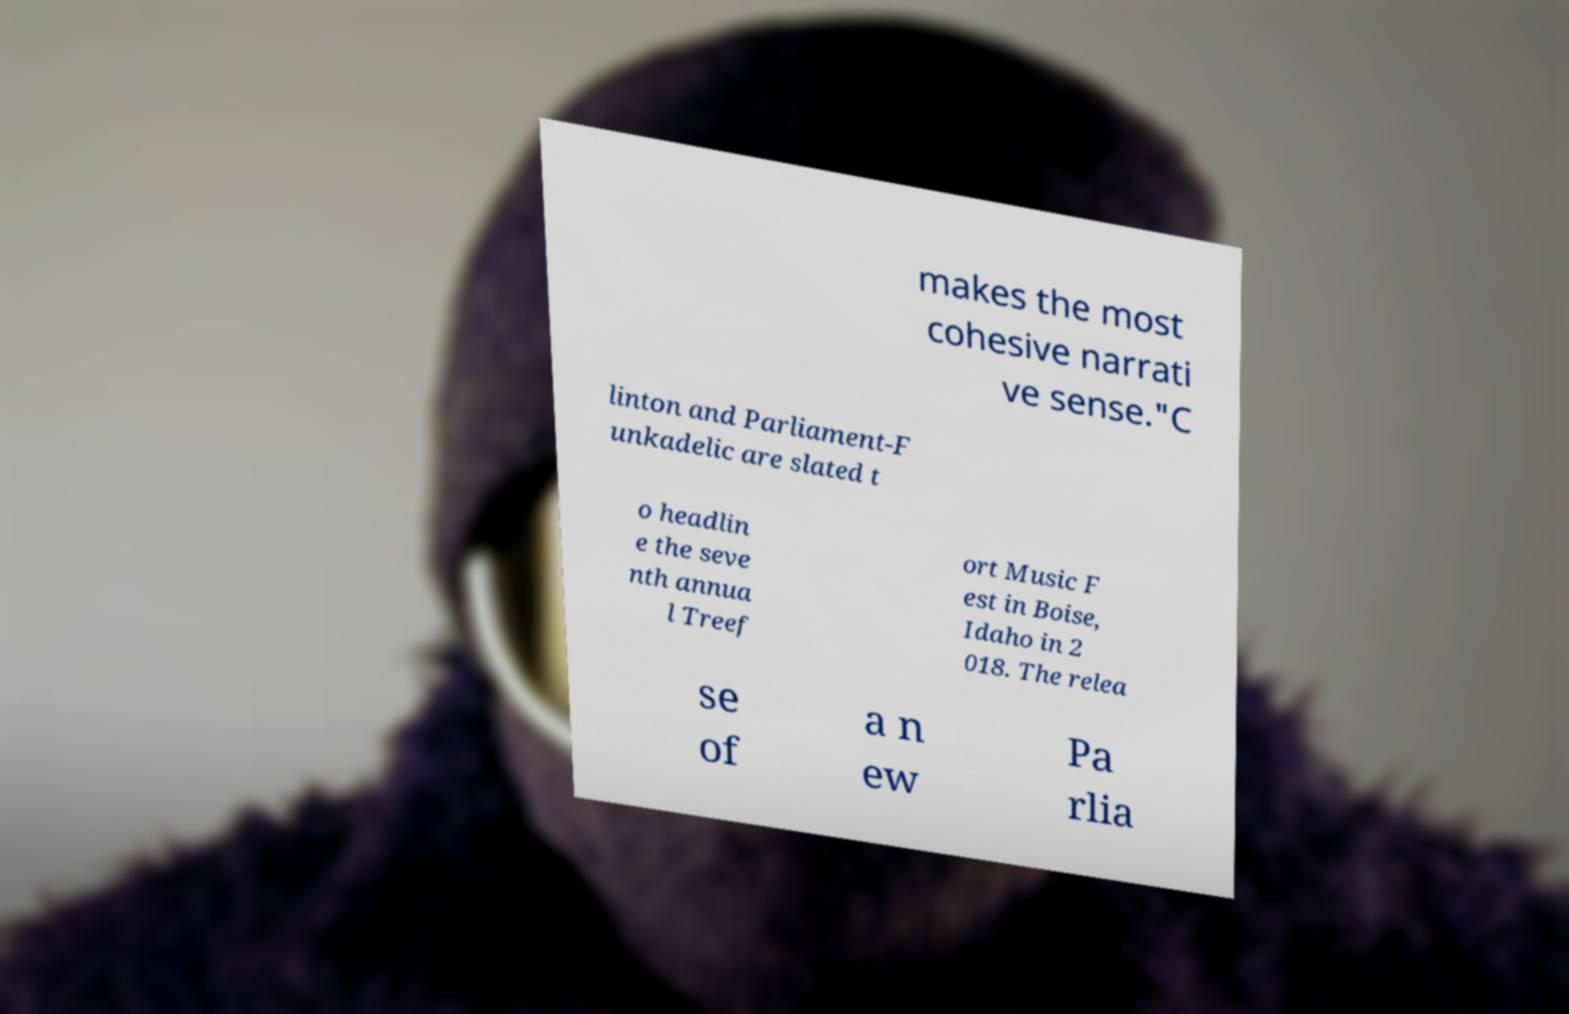Could you extract and type out the text from this image? makes the most cohesive narrati ve sense."C linton and Parliament-F unkadelic are slated t o headlin e the seve nth annua l Treef ort Music F est in Boise, Idaho in 2 018. The relea se of a n ew Pa rlia 